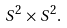<formula> <loc_0><loc_0><loc_500><loc_500>S ^ { 2 } \times S ^ { 2 } .</formula> 